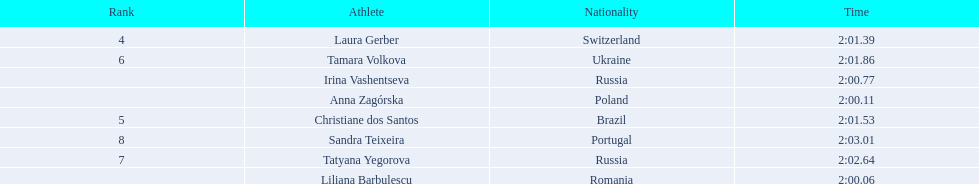What are the names of the competitors? Liliana Barbulescu, Anna Zagórska, Irina Vashentseva, Laura Gerber, Christiane dos Santos, Tamara Volkova, Tatyana Yegorova, Sandra Teixeira. Which finalist finished the fastest? Liliana Barbulescu. Write the full table. {'header': ['Rank', 'Athlete', 'Nationality', 'Time'], 'rows': [['4', 'Laura Gerber', 'Switzerland', '2:01.39'], ['6', 'Tamara Volkova', 'Ukraine', '2:01.86'], ['', 'Irina Vashentseva', 'Russia', '2:00.77'], ['', 'Anna Zagórska', 'Poland', '2:00.11'], ['5', 'Christiane dos Santos', 'Brazil', '2:01.53'], ['8', 'Sandra Teixeira', 'Portugal', '2:03.01'], ['7', 'Tatyana Yegorova', 'Russia', '2:02.64'], ['', 'Liliana Barbulescu', 'Romania', '2:00.06']]} 